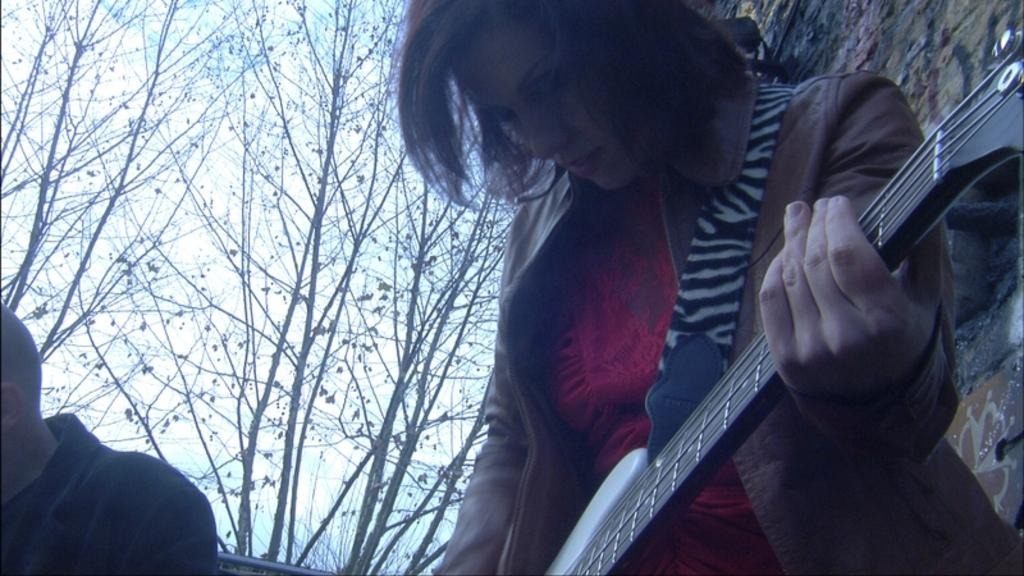How many people are in the image? There are two persons in the image. What is one of the persons holding? One of the persons is holding a guitar. What can be seen in the background of the image? There are trees and the sky visible in the background of the image. What type of beast can be seen playing with tomatoes in the image? There is no beast or tomatoes present in the image; it features two persons and a guitar. 